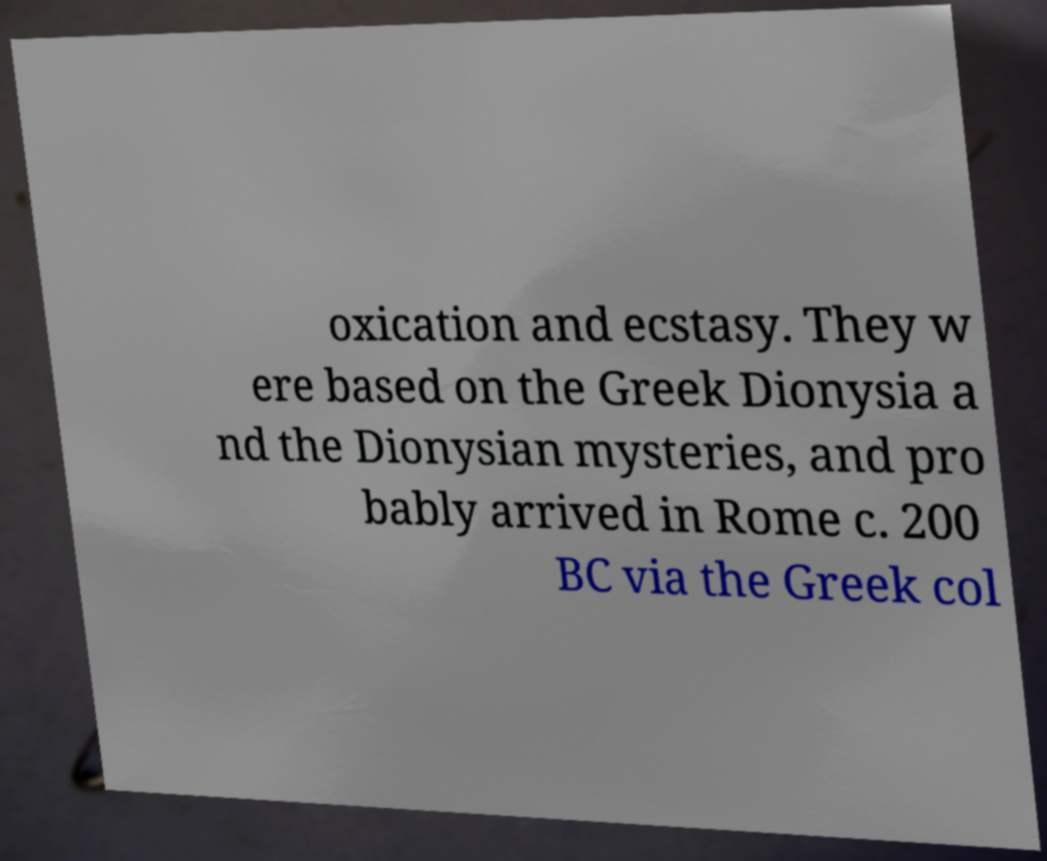Please read and relay the text visible in this image. What does it say? oxication and ecstasy. They w ere based on the Greek Dionysia a nd the Dionysian mysteries, and pro bably arrived in Rome c. 200 BC via the Greek col 